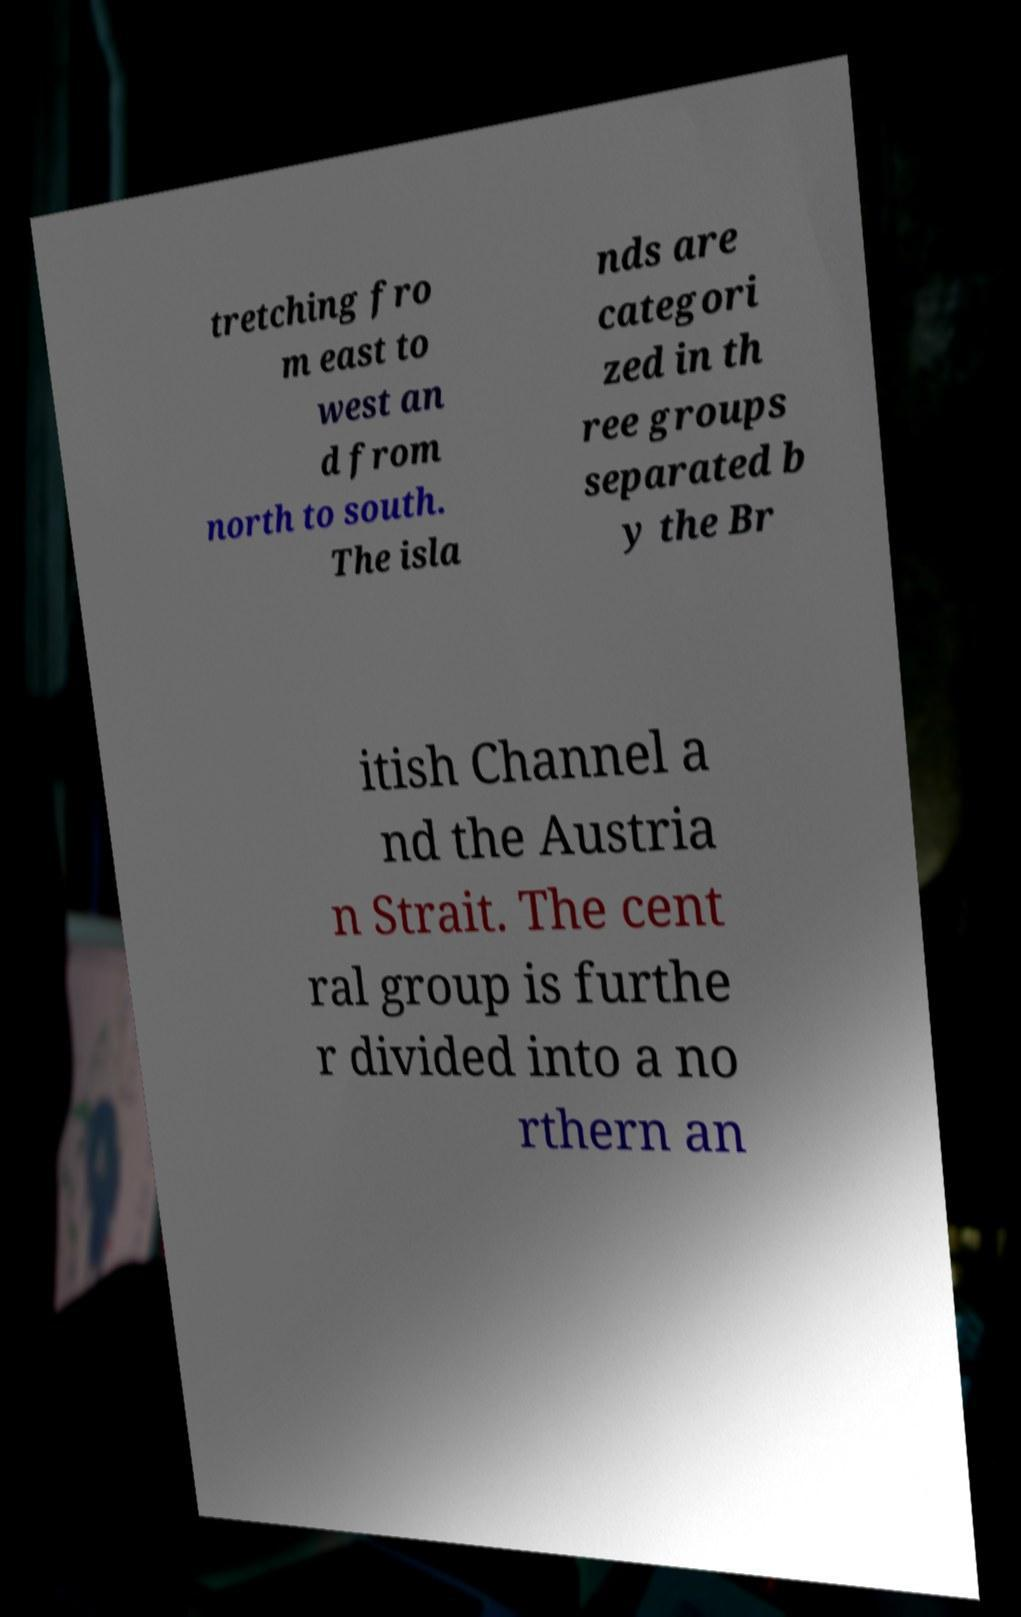Can you read and provide the text displayed in the image?This photo seems to have some interesting text. Can you extract and type it out for me? tretching fro m east to west an d from north to south. The isla nds are categori zed in th ree groups separated b y the Br itish Channel a nd the Austria n Strait. The cent ral group is furthe r divided into a no rthern an 